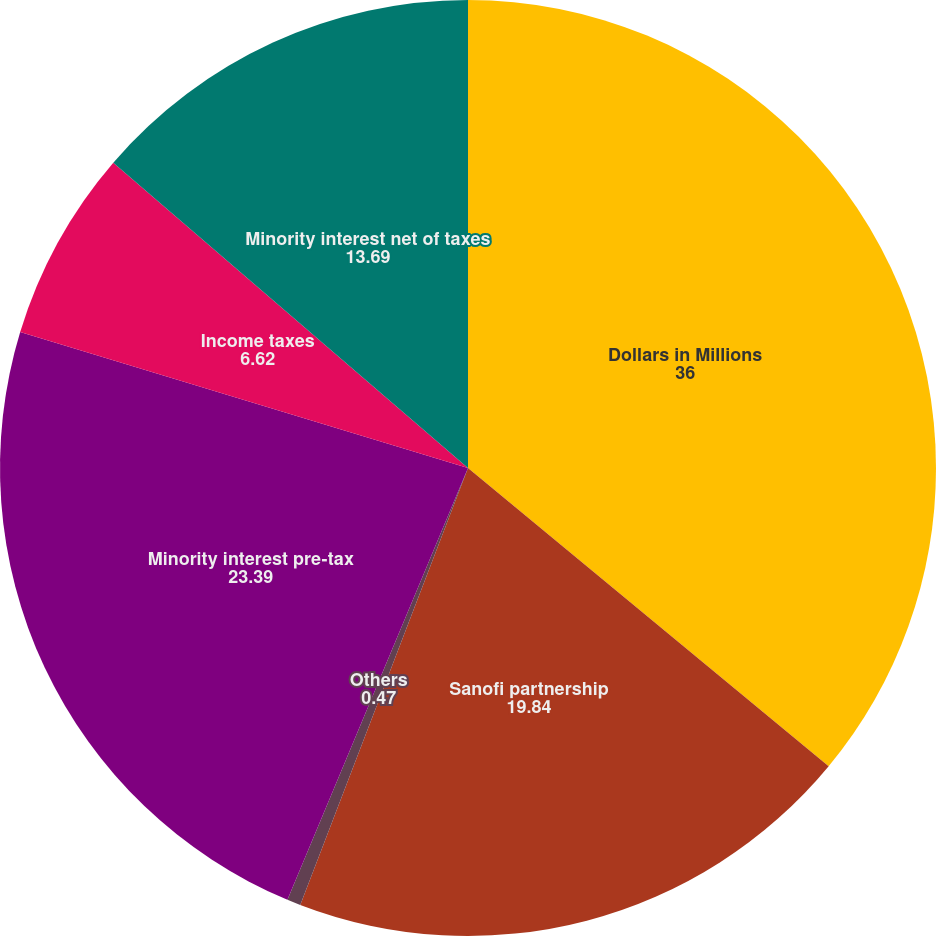<chart> <loc_0><loc_0><loc_500><loc_500><pie_chart><fcel>Dollars in Millions<fcel>Sanofi partnership<fcel>Others<fcel>Minority interest pre-tax<fcel>Income taxes<fcel>Minority interest net of taxes<nl><fcel>36.0%<fcel>19.84%<fcel>0.47%<fcel>23.39%<fcel>6.62%<fcel>13.69%<nl></chart> 